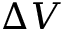Convert formula to latex. <formula><loc_0><loc_0><loc_500><loc_500>\Delta V</formula> 